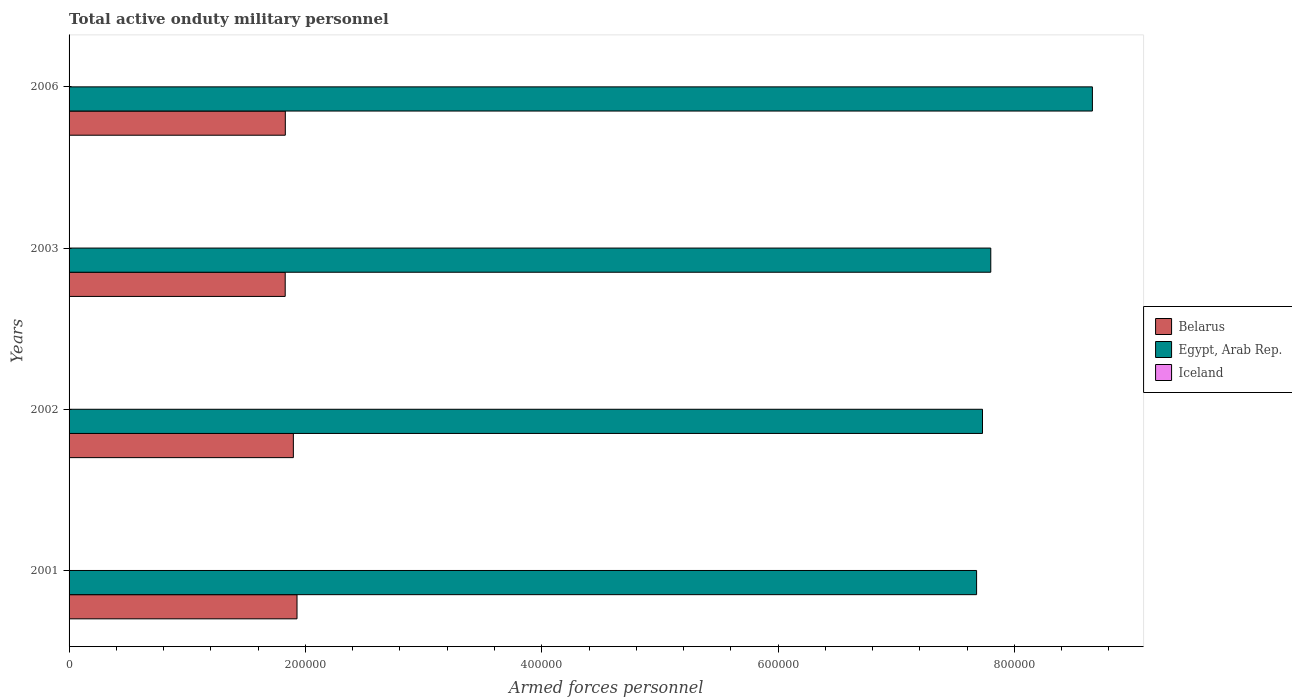Are the number of bars per tick equal to the number of legend labels?
Your answer should be compact. Yes. Are the number of bars on each tick of the Y-axis equal?
Provide a short and direct response. Yes. How many bars are there on the 4th tick from the bottom?
Offer a very short reply. 3. What is the number of armed forces personnel in Belarus in 2006?
Give a very brief answer. 1.83e+05. Across all years, what is the maximum number of armed forces personnel in Belarus?
Offer a very short reply. 1.93e+05. In which year was the number of armed forces personnel in Belarus maximum?
Provide a short and direct response. 2001. In which year was the number of armed forces personnel in Egypt, Arab Rep. minimum?
Offer a terse response. 2001. What is the total number of armed forces personnel in Egypt, Arab Rep. in the graph?
Your answer should be very brief. 3.19e+06. What is the difference between the number of armed forces personnel in Belarus in 2002 and that in 2003?
Make the answer very short. 6900. What is the difference between the number of armed forces personnel in Belarus in 2001 and the number of armed forces personnel in Egypt, Arab Rep. in 2002?
Provide a short and direct response. -5.80e+05. What is the average number of armed forces personnel in Egypt, Arab Rep. per year?
Your answer should be very brief. 7.97e+05. In the year 2006, what is the difference between the number of armed forces personnel in Egypt, Arab Rep. and number of armed forces personnel in Iceland?
Provide a succinct answer. 8.66e+05. In how many years, is the number of armed forces personnel in Iceland greater than 240000 ?
Offer a very short reply. 0. What is the ratio of the number of armed forces personnel in Iceland in 2001 to that in 2006?
Your response must be concise. 0.77. Is the number of armed forces personnel in Egypt, Arab Rep. in 2001 less than that in 2002?
Keep it short and to the point. Yes. Is the difference between the number of armed forces personnel in Egypt, Arab Rep. in 2001 and 2006 greater than the difference between the number of armed forces personnel in Iceland in 2001 and 2006?
Offer a terse response. No. What is the difference between the highest and the second highest number of armed forces personnel in Belarus?
Your answer should be very brief. 3100. In how many years, is the number of armed forces personnel in Iceland greater than the average number of armed forces personnel in Iceland taken over all years?
Keep it short and to the point. 1. What does the 3rd bar from the top in 2003 represents?
Your answer should be very brief. Belarus. What does the 1st bar from the bottom in 2002 represents?
Give a very brief answer. Belarus. How many bars are there?
Keep it short and to the point. 12. Are all the bars in the graph horizontal?
Your response must be concise. Yes. How many years are there in the graph?
Ensure brevity in your answer.  4. Are the values on the major ticks of X-axis written in scientific E-notation?
Provide a short and direct response. No. Does the graph contain grids?
Ensure brevity in your answer.  No. How are the legend labels stacked?
Provide a short and direct response. Vertical. What is the title of the graph?
Offer a terse response. Total active onduty military personnel. What is the label or title of the X-axis?
Provide a short and direct response. Armed forces personnel. What is the label or title of the Y-axis?
Your answer should be compact. Years. What is the Armed forces personnel in Belarus in 2001?
Make the answer very short. 1.93e+05. What is the Armed forces personnel in Egypt, Arab Rep. in 2001?
Offer a terse response. 7.68e+05. What is the Armed forces personnel in Belarus in 2002?
Your response must be concise. 1.90e+05. What is the Armed forces personnel of Egypt, Arab Rep. in 2002?
Offer a terse response. 7.73e+05. What is the Armed forces personnel of Iceland in 2002?
Ensure brevity in your answer.  100. What is the Armed forces personnel of Belarus in 2003?
Give a very brief answer. 1.83e+05. What is the Armed forces personnel in Egypt, Arab Rep. in 2003?
Your answer should be compact. 7.80e+05. What is the Armed forces personnel in Belarus in 2006?
Your answer should be very brief. 1.83e+05. What is the Armed forces personnel in Egypt, Arab Rep. in 2006?
Give a very brief answer. 8.66e+05. What is the Armed forces personnel in Iceland in 2006?
Your answer should be compact. 130. Across all years, what is the maximum Armed forces personnel in Belarus?
Your answer should be very brief. 1.93e+05. Across all years, what is the maximum Armed forces personnel in Egypt, Arab Rep.?
Give a very brief answer. 8.66e+05. Across all years, what is the maximum Armed forces personnel of Iceland?
Offer a very short reply. 130. Across all years, what is the minimum Armed forces personnel in Belarus?
Your response must be concise. 1.83e+05. Across all years, what is the minimum Armed forces personnel of Egypt, Arab Rep.?
Make the answer very short. 7.68e+05. Across all years, what is the minimum Armed forces personnel in Iceland?
Make the answer very short. 100. What is the total Armed forces personnel in Belarus in the graph?
Give a very brief answer. 7.49e+05. What is the total Armed forces personnel of Egypt, Arab Rep. in the graph?
Give a very brief answer. 3.19e+06. What is the total Armed forces personnel of Iceland in the graph?
Your answer should be compact. 430. What is the difference between the Armed forces personnel in Belarus in 2001 and that in 2002?
Keep it short and to the point. 3100. What is the difference between the Armed forces personnel in Egypt, Arab Rep. in 2001 and that in 2002?
Ensure brevity in your answer.  -5000. What is the difference between the Armed forces personnel of Iceland in 2001 and that in 2002?
Keep it short and to the point. 0. What is the difference between the Armed forces personnel in Egypt, Arab Rep. in 2001 and that in 2003?
Your response must be concise. -1.20e+04. What is the difference between the Armed forces personnel of Belarus in 2001 and that in 2006?
Give a very brief answer. 9900. What is the difference between the Armed forces personnel of Egypt, Arab Rep. in 2001 and that in 2006?
Provide a short and direct response. -9.80e+04. What is the difference between the Armed forces personnel in Iceland in 2001 and that in 2006?
Give a very brief answer. -30. What is the difference between the Armed forces personnel in Belarus in 2002 and that in 2003?
Keep it short and to the point. 6900. What is the difference between the Armed forces personnel in Egypt, Arab Rep. in 2002 and that in 2003?
Offer a terse response. -7000. What is the difference between the Armed forces personnel of Iceland in 2002 and that in 2003?
Your response must be concise. 0. What is the difference between the Armed forces personnel in Belarus in 2002 and that in 2006?
Provide a succinct answer. 6800. What is the difference between the Armed forces personnel of Egypt, Arab Rep. in 2002 and that in 2006?
Your answer should be very brief. -9.30e+04. What is the difference between the Armed forces personnel in Belarus in 2003 and that in 2006?
Keep it short and to the point. -100. What is the difference between the Armed forces personnel in Egypt, Arab Rep. in 2003 and that in 2006?
Keep it short and to the point. -8.60e+04. What is the difference between the Armed forces personnel in Iceland in 2003 and that in 2006?
Offer a very short reply. -30. What is the difference between the Armed forces personnel in Belarus in 2001 and the Armed forces personnel in Egypt, Arab Rep. in 2002?
Keep it short and to the point. -5.80e+05. What is the difference between the Armed forces personnel in Belarus in 2001 and the Armed forces personnel in Iceland in 2002?
Provide a short and direct response. 1.93e+05. What is the difference between the Armed forces personnel in Egypt, Arab Rep. in 2001 and the Armed forces personnel in Iceland in 2002?
Your answer should be compact. 7.68e+05. What is the difference between the Armed forces personnel of Belarus in 2001 and the Armed forces personnel of Egypt, Arab Rep. in 2003?
Ensure brevity in your answer.  -5.87e+05. What is the difference between the Armed forces personnel in Belarus in 2001 and the Armed forces personnel in Iceland in 2003?
Make the answer very short. 1.93e+05. What is the difference between the Armed forces personnel in Egypt, Arab Rep. in 2001 and the Armed forces personnel in Iceland in 2003?
Give a very brief answer. 7.68e+05. What is the difference between the Armed forces personnel in Belarus in 2001 and the Armed forces personnel in Egypt, Arab Rep. in 2006?
Provide a succinct answer. -6.73e+05. What is the difference between the Armed forces personnel in Belarus in 2001 and the Armed forces personnel in Iceland in 2006?
Offer a terse response. 1.93e+05. What is the difference between the Armed forces personnel of Egypt, Arab Rep. in 2001 and the Armed forces personnel of Iceland in 2006?
Provide a succinct answer. 7.68e+05. What is the difference between the Armed forces personnel of Belarus in 2002 and the Armed forces personnel of Egypt, Arab Rep. in 2003?
Keep it short and to the point. -5.90e+05. What is the difference between the Armed forces personnel of Belarus in 2002 and the Armed forces personnel of Iceland in 2003?
Your answer should be compact. 1.90e+05. What is the difference between the Armed forces personnel of Egypt, Arab Rep. in 2002 and the Armed forces personnel of Iceland in 2003?
Offer a terse response. 7.73e+05. What is the difference between the Armed forces personnel of Belarus in 2002 and the Armed forces personnel of Egypt, Arab Rep. in 2006?
Make the answer very short. -6.76e+05. What is the difference between the Armed forces personnel of Belarus in 2002 and the Armed forces personnel of Iceland in 2006?
Your answer should be compact. 1.90e+05. What is the difference between the Armed forces personnel in Egypt, Arab Rep. in 2002 and the Armed forces personnel in Iceland in 2006?
Your answer should be compact. 7.73e+05. What is the difference between the Armed forces personnel of Belarus in 2003 and the Armed forces personnel of Egypt, Arab Rep. in 2006?
Offer a terse response. -6.83e+05. What is the difference between the Armed forces personnel of Belarus in 2003 and the Armed forces personnel of Iceland in 2006?
Make the answer very short. 1.83e+05. What is the difference between the Armed forces personnel of Egypt, Arab Rep. in 2003 and the Armed forces personnel of Iceland in 2006?
Your answer should be very brief. 7.80e+05. What is the average Armed forces personnel in Belarus per year?
Provide a succinct answer. 1.87e+05. What is the average Armed forces personnel in Egypt, Arab Rep. per year?
Keep it short and to the point. 7.97e+05. What is the average Armed forces personnel in Iceland per year?
Provide a succinct answer. 107.5. In the year 2001, what is the difference between the Armed forces personnel of Belarus and Armed forces personnel of Egypt, Arab Rep.?
Keep it short and to the point. -5.75e+05. In the year 2001, what is the difference between the Armed forces personnel of Belarus and Armed forces personnel of Iceland?
Provide a short and direct response. 1.93e+05. In the year 2001, what is the difference between the Armed forces personnel of Egypt, Arab Rep. and Armed forces personnel of Iceland?
Provide a short and direct response. 7.68e+05. In the year 2002, what is the difference between the Armed forces personnel of Belarus and Armed forces personnel of Egypt, Arab Rep.?
Offer a terse response. -5.83e+05. In the year 2002, what is the difference between the Armed forces personnel of Belarus and Armed forces personnel of Iceland?
Your answer should be compact. 1.90e+05. In the year 2002, what is the difference between the Armed forces personnel of Egypt, Arab Rep. and Armed forces personnel of Iceland?
Offer a very short reply. 7.73e+05. In the year 2003, what is the difference between the Armed forces personnel in Belarus and Armed forces personnel in Egypt, Arab Rep.?
Your answer should be very brief. -5.97e+05. In the year 2003, what is the difference between the Armed forces personnel of Belarus and Armed forces personnel of Iceland?
Provide a short and direct response. 1.83e+05. In the year 2003, what is the difference between the Armed forces personnel in Egypt, Arab Rep. and Armed forces personnel in Iceland?
Give a very brief answer. 7.80e+05. In the year 2006, what is the difference between the Armed forces personnel of Belarus and Armed forces personnel of Egypt, Arab Rep.?
Provide a short and direct response. -6.83e+05. In the year 2006, what is the difference between the Armed forces personnel in Belarus and Armed forces personnel in Iceland?
Make the answer very short. 1.83e+05. In the year 2006, what is the difference between the Armed forces personnel of Egypt, Arab Rep. and Armed forces personnel of Iceland?
Your answer should be very brief. 8.66e+05. What is the ratio of the Armed forces personnel in Belarus in 2001 to that in 2002?
Ensure brevity in your answer.  1.02. What is the ratio of the Armed forces personnel of Iceland in 2001 to that in 2002?
Provide a succinct answer. 1. What is the ratio of the Armed forces personnel of Belarus in 2001 to that in 2003?
Ensure brevity in your answer.  1.05. What is the ratio of the Armed forces personnel of Egypt, Arab Rep. in 2001 to that in 2003?
Make the answer very short. 0.98. What is the ratio of the Armed forces personnel of Iceland in 2001 to that in 2003?
Give a very brief answer. 1. What is the ratio of the Armed forces personnel of Belarus in 2001 to that in 2006?
Ensure brevity in your answer.  1.05. What is the ratio of the Armed forces personnel of Egypt, Arab Rep. in 2001 to that in 2006?
Provide a short and direct response. 0.89. What is the ratio of the Armed forces personnel in Iceland in 2001 to that in 2006?
Provide a short and direct response. 0.77. What is the ratio of the Armed forces personnel of Belarus in 2002 to that in 2003?
Your answer should be very brief. 1.04. What is the ratio of the Armed forces personnel in Iceland in 2002 to that in 2003?
Make the answer very short. 1. What is the ratio of the Armed forces personnel of Belarus in 2002 to that in 2006?
Your response must be concise. 1.04. What is the ratio of the Armed forces personnel of Egypt, Arab Rep. in 2002 to that in 2006?
Give a very brief answer. 0.89. What is the ratio of the Armed forces personnel in Iceland in 2002 to that in 2006?
Give a very brief answer. 0.77. What is the ratio of the Armed forces personnel of Egypt, Arab Rep. in 2003 to that in 2006?
Your answer should be very brief. 0.9. What is the ratio of the Armed forces personnel of Iceland in 2003 to that in 2006?
Keep it short and to the point. 0.77. What is the difference between the highest and the second highest Armed forces personnel in Belarus?
Keep it short and to the point. 3100. What is the difference between the highest and the second highest Armed forces personnel of Egypt, Arab Rep.?
Offer a terse response. 8.60e+04. What is the difference between the highest and the second highest Armed forces personnel of Iceland?
Your answer should be very brief. 30. What is the difference between the highest and the lowest Armed forces personnel of Egypt, Arab Rep.?
Keep it short and to the point. 9.80e+04. What is the difference between the highest and the lowest Armed forces personnel of Iceland?
Make the answer very short. 30. 